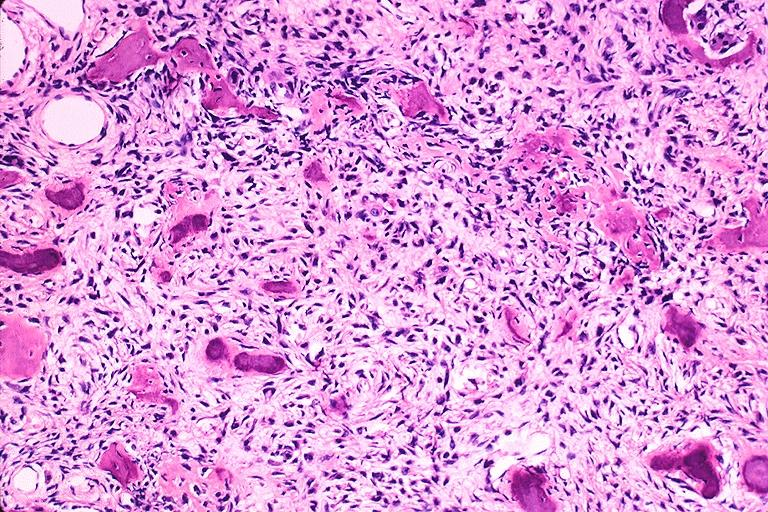what is present?
Answer the question using a single word or phrase. Oral 